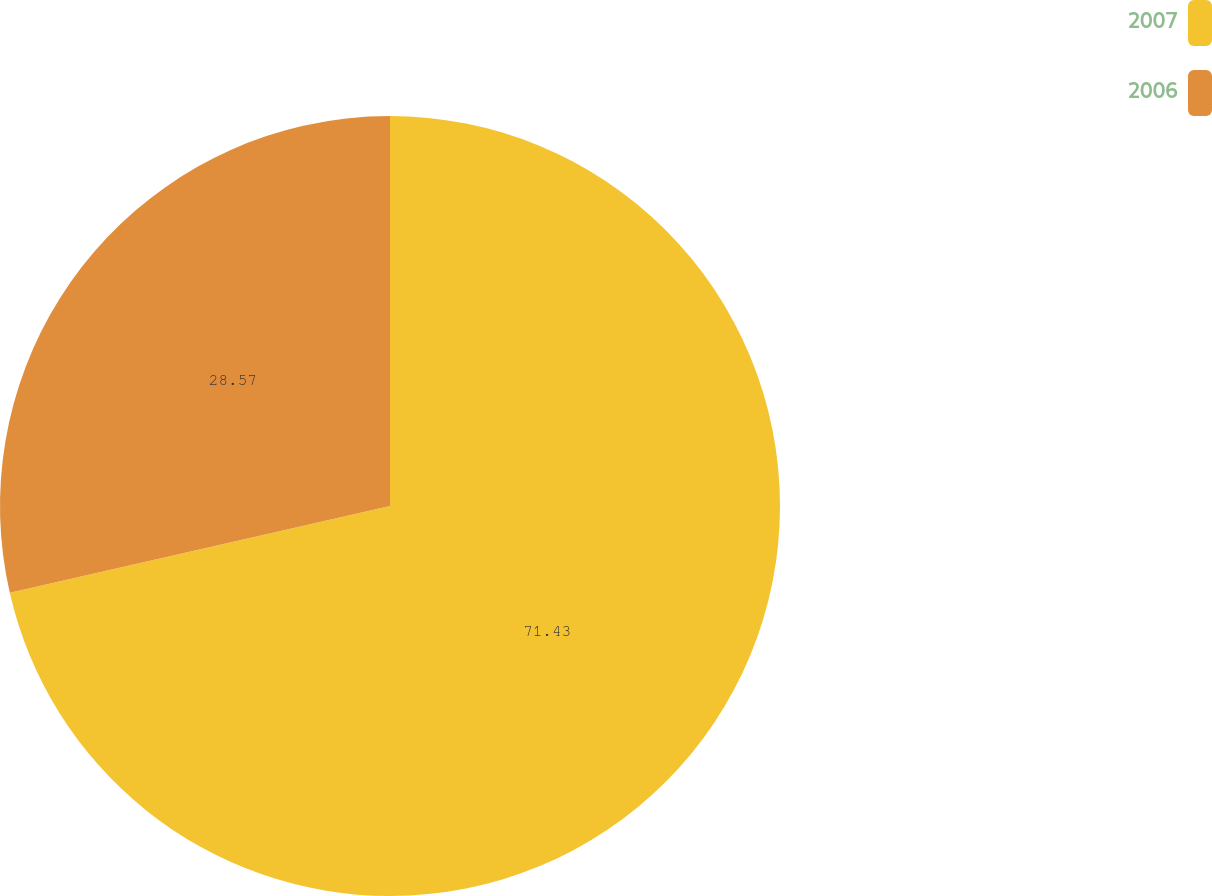Convert chart to OTSL. <chart><loc_0><loc_0><loc_500><loc_500><pie_chart><fcel>2007<fcel>2006<nl><fcel>71.43%<fcel>28.57%<nl></chart> 